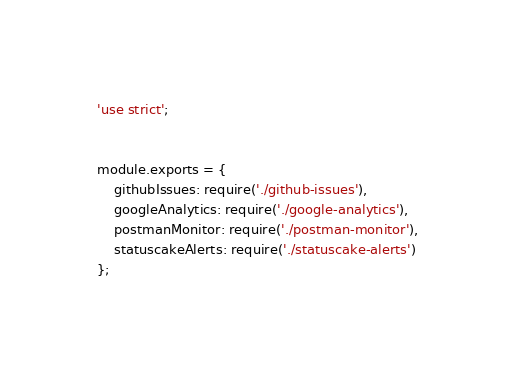<code> <loc_0><loc_0><loc_500><loc_500><_JavaScript_>'use strict';


module.exports = {
	githubIssues: require('./github-issues'),
	googleAnalytics: require('./google-analytics'),
	postmanMonitor: require('./postman-monitor'),
	statuscakeAlerts: require('./statuscake-alerts')
};
</code> 